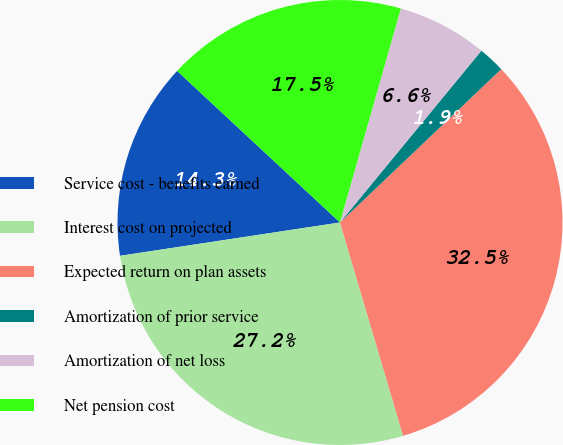<chart> <loc_0><loc_0><loc_500><loc_500><pie_chart><fcel>Service cost - benefits earned<fcel>Interest cost on projected<fcel>Expected return on plan assets<fcel>Amortization of prior service<fcel>Amortization of net loss<fcel>Net pension cost<nl><fcel>14.32%<fcel>27.18%<fcel>32.52%<fcel>1.94%<fcel>6.55%<fcel>17.48%<nl></chart> 